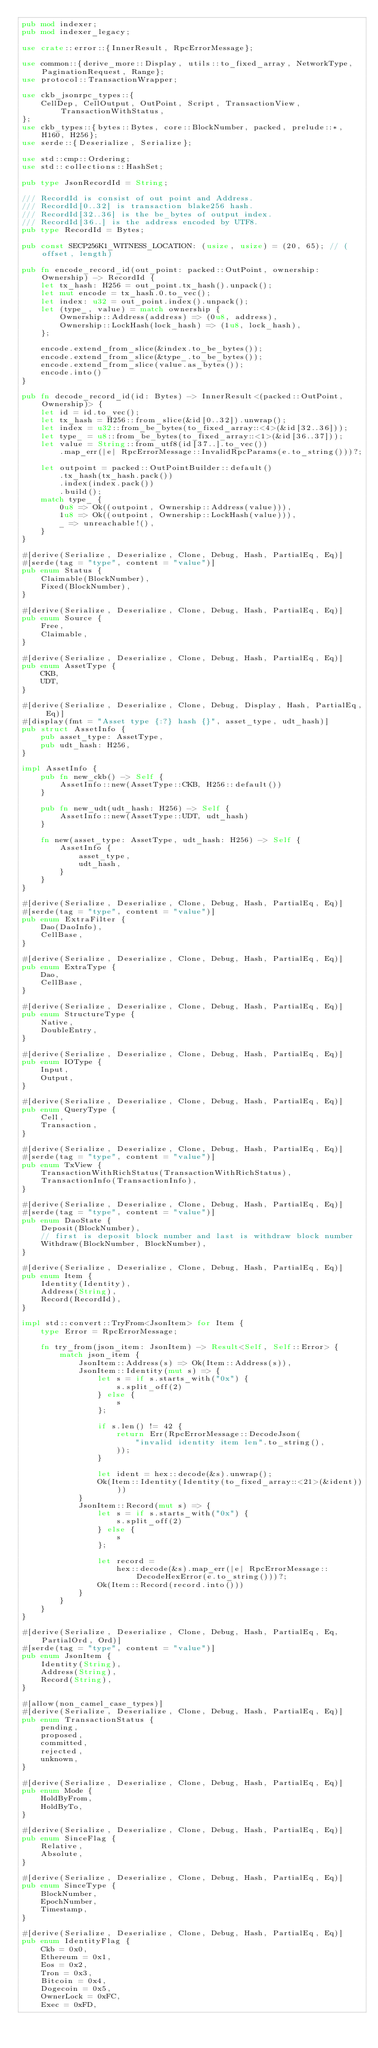<code> <loc_0><loc_0><loc_500><loc_500><_Rust_>pub mod indexer;
pub mod indexer_legacy;

use crate::error::{InnerResult, RpcErrorMessage};

use common::{derive_more::Display, utils::to_fixed_array, NetworkType, PaginationRequest, Range};
use protocol::TransactionWrapper;

use ckb_jsonrpc_types::{
    CellDep, CellOutput, OutPoint, Script, TransactionView, TransactionWithStatus,
};
use ckb_types::{bytes::Bytes, core::BlockNumber, packed, prelude::*, H160, H256};
use serde::{Deserialize, Serialize};

use std::cmp::Ordering;
use std::collections::HashSet;

pub type JsonRecordId = String;

/// RecordId is consist of out point and Address.
/// RecordId[0..32] is transaction blake256 hash.
/// RecordId[32..36] is the be_bytes of output index.
/// RecordId[36..] is the address encoded by UTF8.
pub type RecordId = Bytes;

pub const SECP256K1_WITNESS_LOCATION: (usize, usize) = (20, 65); // (offset, length)

pub fn encode_record_id(out_point: packed::OutPoint, ownership: Ownership) -> RecordId {
    let tx_hash: H256 = out_point.tx_hash().unpack();
    let mut encode = tx_hash.0.to_vec();
    let index: u32 = out_point.index().unpack();
    let (type_, value) = match ownership {
        Ownership::Address(address) => (0u8, address),
        Ownership::LockHash(lock_hash) => (1u8, lock_hash),
    };

    encode.extend_from_slice(&index.to_be_bytes());
    encode.extend_from_slice(&type_.to_be_bytes());
    encode.extend_from_slice(value.as_bytes());
    encode.into()
}

pub fn decode_record_id(id: Bytes) -> InnerResult<(packed::OutPoint, Ownership)> {
    let id = id.to_vec();
    let tx_hash = H256::from_slice(&id[0..32]).unwrap();
    let index = u32::from_be_bytes(to_fixed_array::<4>(&id[32..36]));
    let type_ = u8::from_be_bytes(to_fixed_array::<1>(&id[36..37]));
    let value = String::from_utf8(id[37..].to_vec())
        .map_err(|e| RpcErrorMessage::InvalidRpcParams(e.to_string()))?;

    let outpoint = packed::OutPointBuilder::default()
        .tx_hash(tx_hash.pack())
        .index(index.pack())
        .build();
    match type_ {
        0u8 => Ok((outpoint, Ownership::Address(value))),
        1u8 => Ok((outpoint, Ownership::LockHash(value))),
        _ => unreachable!(),
    }
}

#[derive(Serialize, Deserialize, Clone, Debug, Hash, PartialEq, Eq)]
#[serde(tag = "type", content = "value")]
pub enum Status {
    Claimable(BlockNumber),
    Fixed(BlockNumber),
}

#[derive(Serialize, Deserialize, Clone, Debug, Hash, PartialEq, Eq)]
pub enum Source {
    Free,
    Claimable,
}

#[derive(Serialize, Deserialize, Clone, Debug, Hash, PartialEq, Eq)]
pub enum AssetType {
    CKB,
    UDT,
}

#[derive(Serialize, Deserialize, Clone, Debug, Display, Hash, PartialEq, Eq)]
#[display(fmt = "Asset type {:?} hash {}", asset_type, udt_hash)]
pub struct AssetInfo {
    pub asset_type: AssetType,
    pub udt_hash: H256,
}

impl AssetInfo {
    pub fn new_ckb() -> Self {
        AssetInfo::new(AssetType::CKB, H256::default())
    }

    pub fn new_udt(udt_hash: H256) -> Self {
        AssetInfo::new(AssetType::UDT, udt_hash)
    }

    fn new(asset_type: AssetType, udt_hash: H256) -> Self {
        AssetInfo {
            asset_type,
            udt_hash,
        }
    }
}

#[derive(Serialize, Deserialize, Clone, Debug, Hash, PartialEq, Eq)]
#[serde(tag = "type", content = "value")]
pub enum ExtraFilter {
    Dao(DaoInfo),
    CellBase,
}

#[derive(Serialize, Deserialize, Clone, Debug, Hash, PartialEq, Eq)]
pub enum ExtraType {
    Dao,
    CellBase,
}

#[derive(Serialize, Deserialize, Clone, Debug, Hash, PartialEq, Eq)]
pub enum StructureType {
    Native,
    DoubleEntry,
}

#[derive(Serialize, Deserialize, Clone, Debug, Hash, PartialEq, Eq)]
pub enum IOType {
    Input,
    Output,
}

#[derive(Serialize, Deserialize, Clone, Debug, Hash, PartialEq, Eq)]
pub enum QueryType {
    Cell,
    Transaction,
}

#[derive(Serialize, Deserialize, Clone, Debug, Hash, PartialEq, Eq)]
#[serde(tag = "type", content = "value")]
pub enum TxView {
    TransactionWithRichStatus(TransactionWithRichStatus),
    TransactionInfo(TransactionInfo),
}

#[derive(Serialize, Deserialize, Clone, Debug, Hash, PartialEq, Eq)]
#[serde(tag = "type", content = "value")]
pub enum DaoState {
    Deposit(BlockNumber),
    // first is deposit block number and last is withdraw block number
    Withdraw(BlockNumber, BlockNumber),
}

#[derive(Serialize, Deserialize, Clone, Debug, Hash, PartialEq, Eq)]
pub enum Item {
    Identity(Identity),
    Address(String),
    Record(RecordId),
}

impl std::convert::TryFrom<JsonItem> for Item {
    type Error = RpcErrorMessage;

    fn try_from(json_item: JsonItem) -> Result<Self, Self::Error> {
        match json_item {
            JsonItem::Address(s) => Ok(Item::Address(s)),
            JsonItem::Identity(mut s) => {
                let s = if s.starts_with("0x") {
                    s.split_off(2)
                } else {
                    s
                };

                if s.len() != 42 {
                    return Err(RpcErrorMessage::DecodeJson(
                        "invalid identity item len".to_string(),
                    ));
                }

                let ident = hex::decode(&s).unwrap();
                Ok(Item::Identity(Identity(to_fixed_array::<21>(&ident))))
            }
            JsonItem::Record(mut s) => {
                let s = if s.starts_with("0x") {
                    s.split_off(2)
                } else {
                    s
                };

                let record =
                    hex::decode(&s).map_err(|e| RpcErrorMessage::DecodeHexError(e.to_string()))?;
                Ok(Item::Record(record.into()))
            }
        }
    }
}

#[derive(Serialize, Deserialize, Clone, Debug, Hash, PartialEq, Eq, PartialOrd, Ord)]
#[serde(tag = "type", content = "value")]
pub enum JsonItem {
    Identity(String),
    Address(String),
    Record(String),
}

#[allow(non_camel_case_types)]
#[derive(Serialize, Deserialize, Clone, Debug, Hash, PartialEq, Eq)]
pub enum TransactionStatus {
    pending,
    proposed,
    committed,
    rejected,
    unknown,
}

#[derive(Serialize, Deserialize, Clone, Debug, Hash, PartialEq, Eq)]
pub enum Mode {
    HoldByFrom,
    HoldByTo,
}

#[derive(Serialize, Deserialize, Clone, Debug, Hash, PartialEq, Eq)]
pub enum SinceFlag {
    Relative,
    Absolute,
}

#[derive(Serialize, Deserialize, Clone, Debug, Hash, PartialEq, Eq)]
pub enum SinceType {
    BlockNumber,
    EpochNumber,
    Timestamp,
}

#[derive(Serialize, Deserialize, Clone, Debug, Hash, PartialEq, Eq)]
pub enum IdentityFlag {
    Ckb = 0x0,
    Ethereum = 0x1,
    Eos = 0x2,
    Tron = 0x3,
    Bitcoin = 0x4,
    Dogecoin = 0x5,
    OwnerLock = 0xFC,
    Exec = 0xFD,</code> 